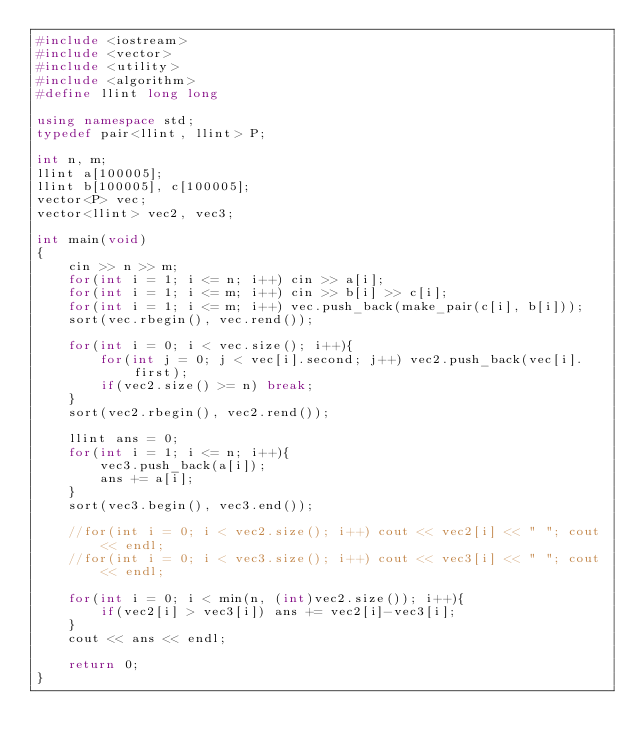<code> <loc_0><loc_0><loc_500><loc_500><_C++_>#include <iostream>
#include <vector>
#include <utility>
#include <algorithm>
#define llint long long

using namespace std;
typedef pair<llint, llint> P;

int n, m;
llint a[100005];
llint b[100005], c[100005];
vector<P> vec;
vector<llint> vec2, vec3;

int main(void)
{
	cin >> n >> m;
	for(int i = 1; i <= n; i++) cin >> a[i];
	for(int i = 1; i <= m; i++) cin >> b[i] >> c[i];
	for(int i = 1; i <= m; i++) vec.push_back(make_pair(c[i], b[i]));
	sort(vec.rbegin(), vec.rend());
	
	for(int i = 0; i < vec.size(); i++){
		for(int j = 0; j < vec[i].second; j++) vec2.push_back(vec[i].first);
		if(vec2.size() >= n) break;
	}
	sort(vec2.rbegin(), vec2.rend());
	
	llint ans = 0;
	for(int i = 1; i <= n; i++){
		vec3.push_back(a[i]);
		ans += a[i];
	}
	sort(vec3.begin(), vec3.end());
	
	//for(int i = 0; i < vec2.size(); i++) cout << vec2[i] << " "; cout << endl;
	//for(int i = 0; i < vec3.size(); i++) cout << vec3[i] << " "; cout << endl;
	
	for(int i = 0; i < min(n, (int)vec2.size()); i++){
		if(vec2[i] > vec3[i]) ans += vec2[i]-vec3[i];
	}
	cout << ans << endl;
	
	return 0;
}</code> 